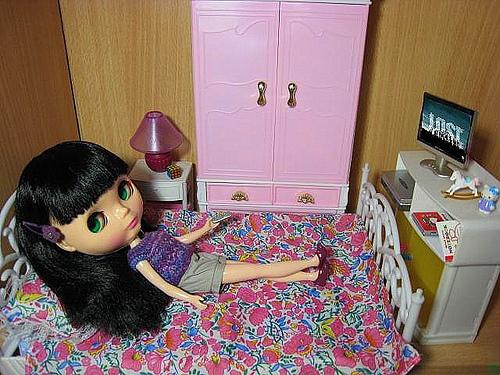Is the bed made?
Answer briefly. Yes. What color is her cabinet?
Write a very short answer. Pink. What is the doll laying on?
Quick response, please. Bed. 